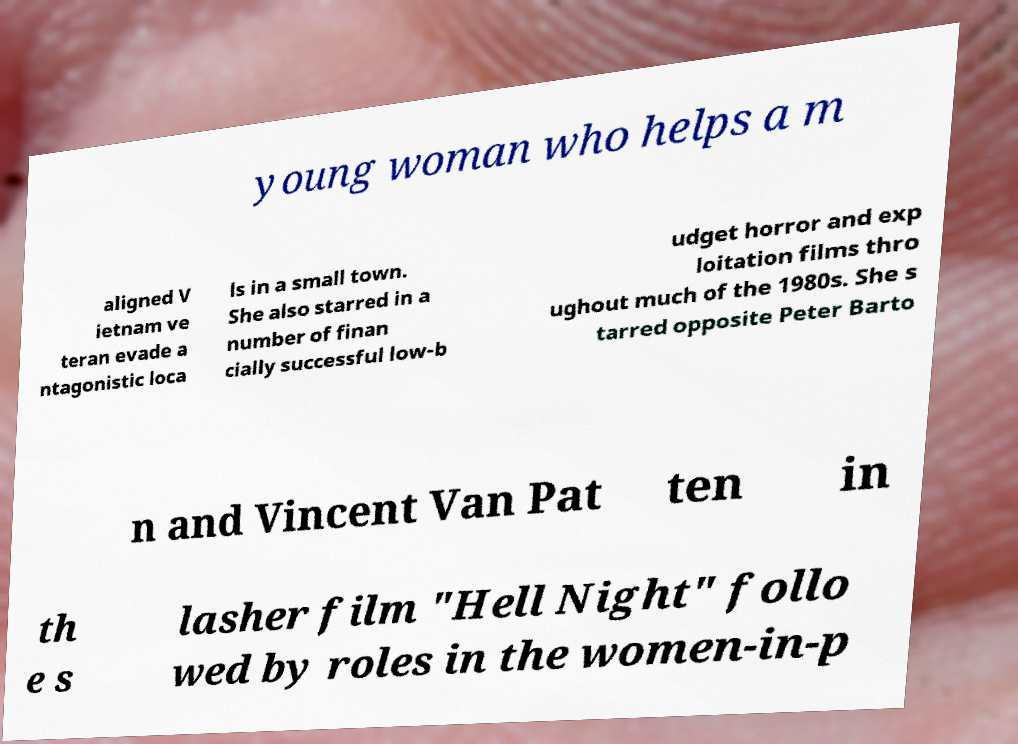I need the written content from this picture converted into text. Can you do that? young woman who helps a m aligned V ietnam ve teran evade a ntagonistic loca ls in a small town. She also starred in a number of finan cially successful low-b udget horror and exp loitation films thro ughout much of the 1980s. She s tarred opposite Peter Barto n and Vincent Van Pat ten in th e s lasher film "Hell Night" follo wed by roles in the women-in-p 